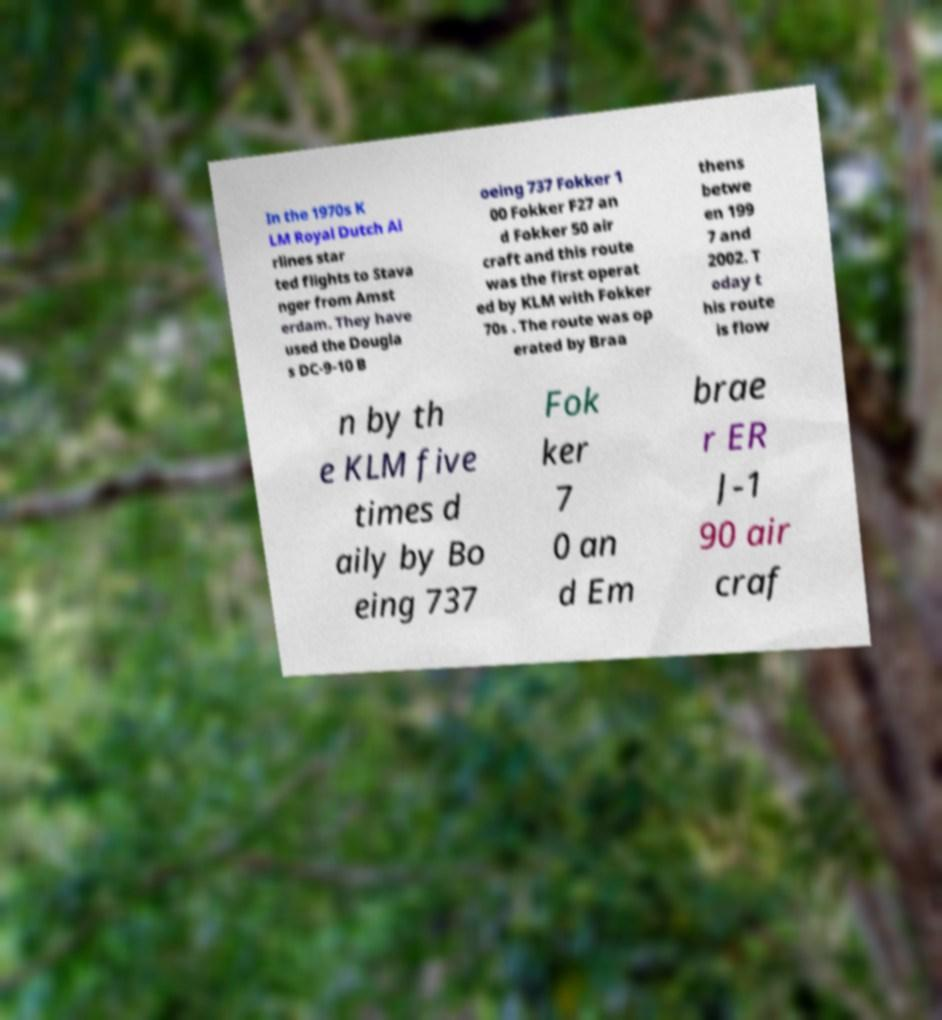There's text embedded in this image that I need extracted. Can you transcribe it verbatim? In the 1970s K LM Royal Dutch Ai rlines star ted flights to Stava nger from Amst erdam. They have used the Dougla s DC-9-10 B oeing 737 Fokker 1 00 Fokker F27 an d Fokker 50 air craft and this route was the first operat ed by KLM with Fokker 70s . The route was op erated by Braa thens betwe en 199 7 and 2002. T oday t his route is flow n by th e KLM five times d aily by Bo eing 737 Fok ker 7 0 an d Em brae r ER J-1 90 air craf 